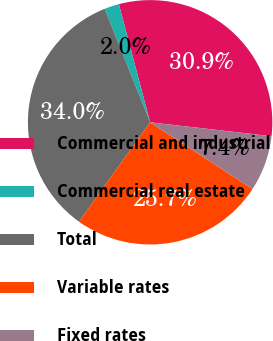Convert chart. <chart><loc_0><loc_0><loc_500><loc_500><pie_chart><fcel>Commercial and industrial<fcel>Commercial real estate<fcel>Total<fcel>Variable rates<fcel>Fixed rates<nl><fcel>30.93%<fcel>1.95%<fcel>34.04%<fcel>25.7%<fcel>7.38%<nl></chart> 